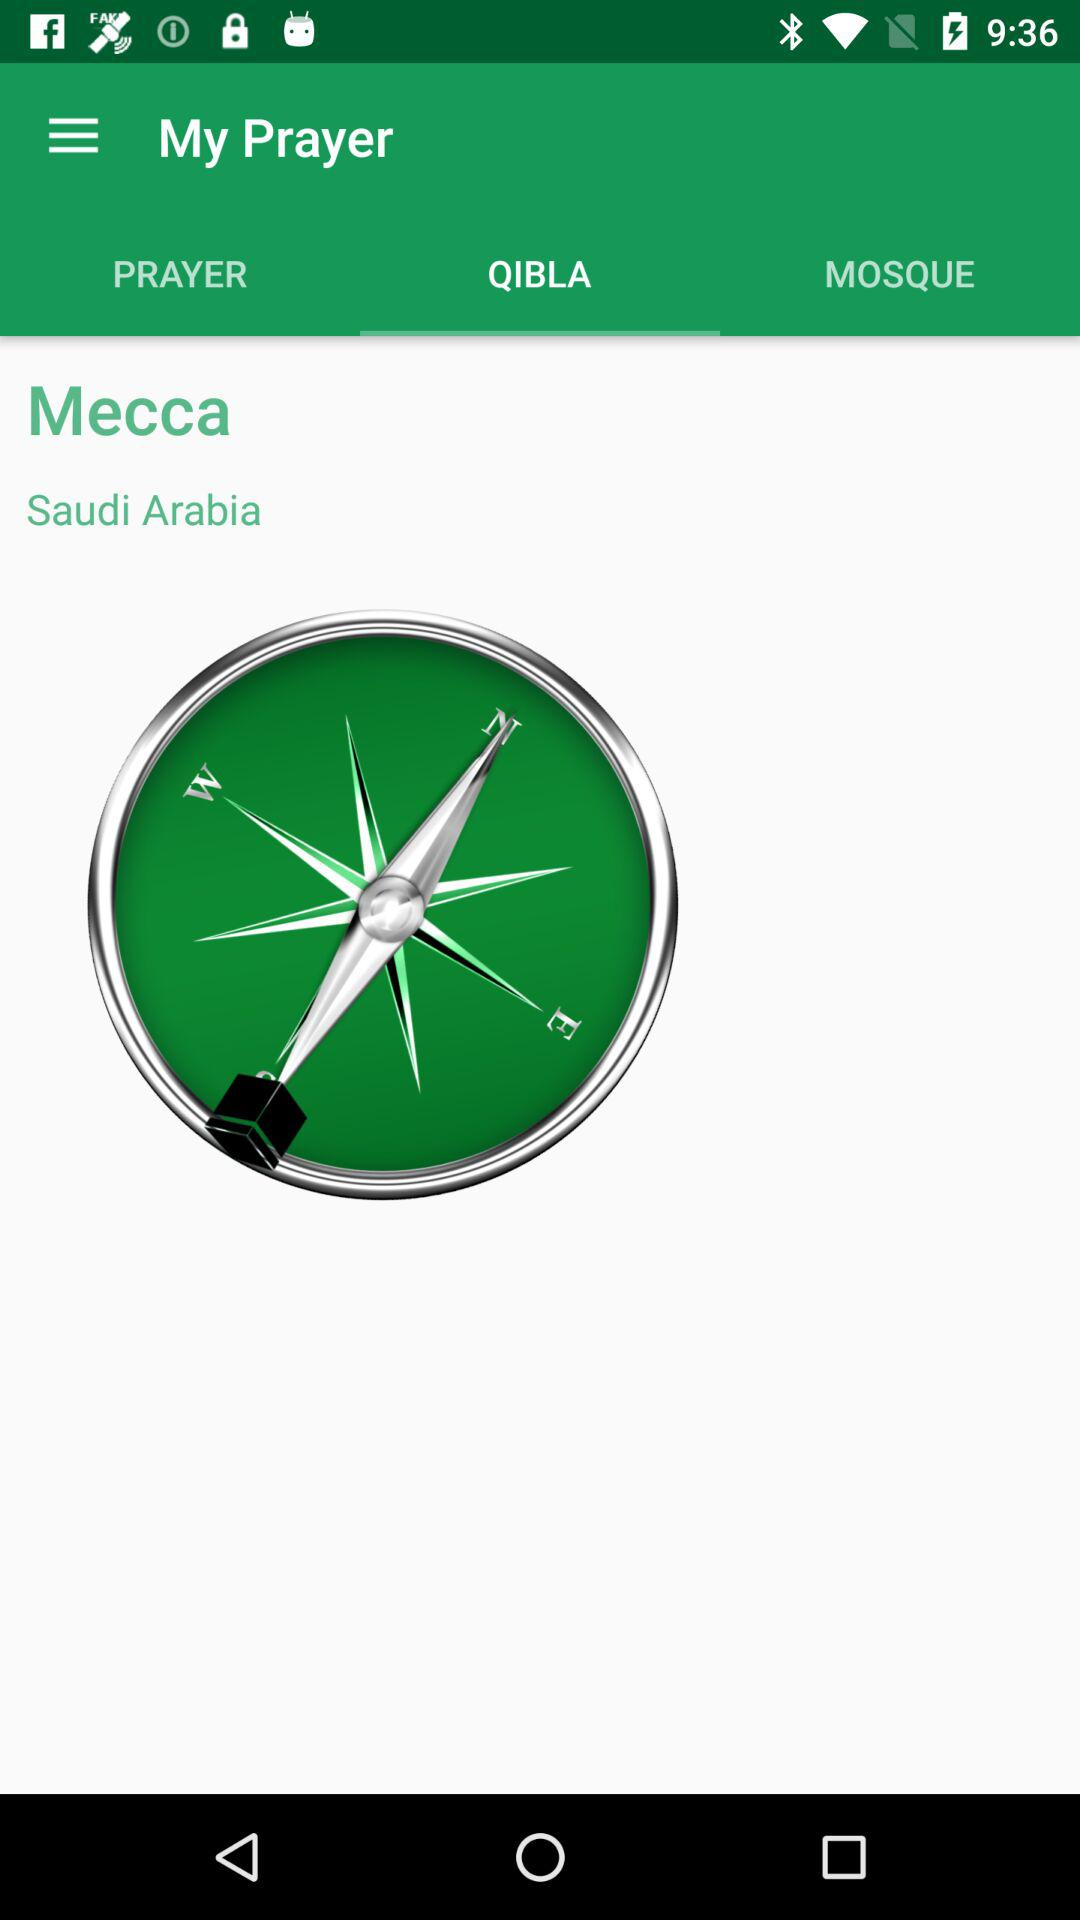Which tab is selected? The selected tab is "QIBLA". 